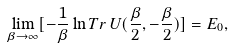<formula> <loc_0><loc_0><loc_500><loc_500>\lim _ { \beta \to \infty } [ - \frac { 1 } { \beta } \ln T r \, U ( \frac { \beta } { 2 } , - \frac { \beta } { 2 } ) ] = E _ { 0 } ,</formula> 